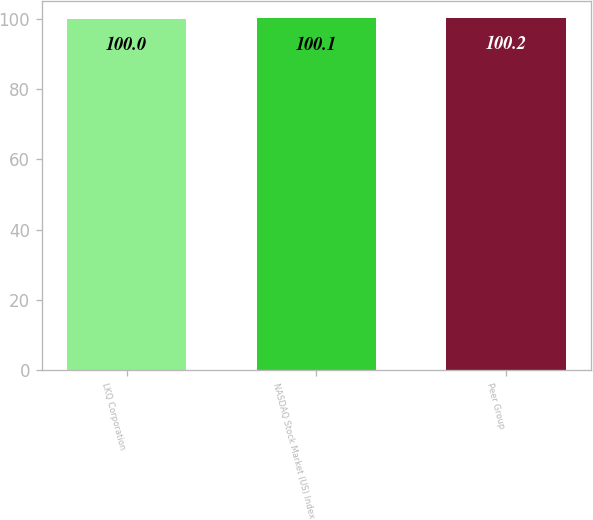Convert chart. <chart><loc_0><loc_0><loc_500><loc_500><bar_chart><fcel>LKQ Corporation<fcel>NASDAQ Stock Market (US) Index<fcel>Peer Group<nl><fcel>100<fcel>100.1<fcel>100.2<nl></chart> 